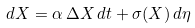<formula> <loc_0><loc_0><loc_500><loc_500>d X = \alpha \, \Delta X \, d t + \sigma ( X ) \, d \eta</formula> 